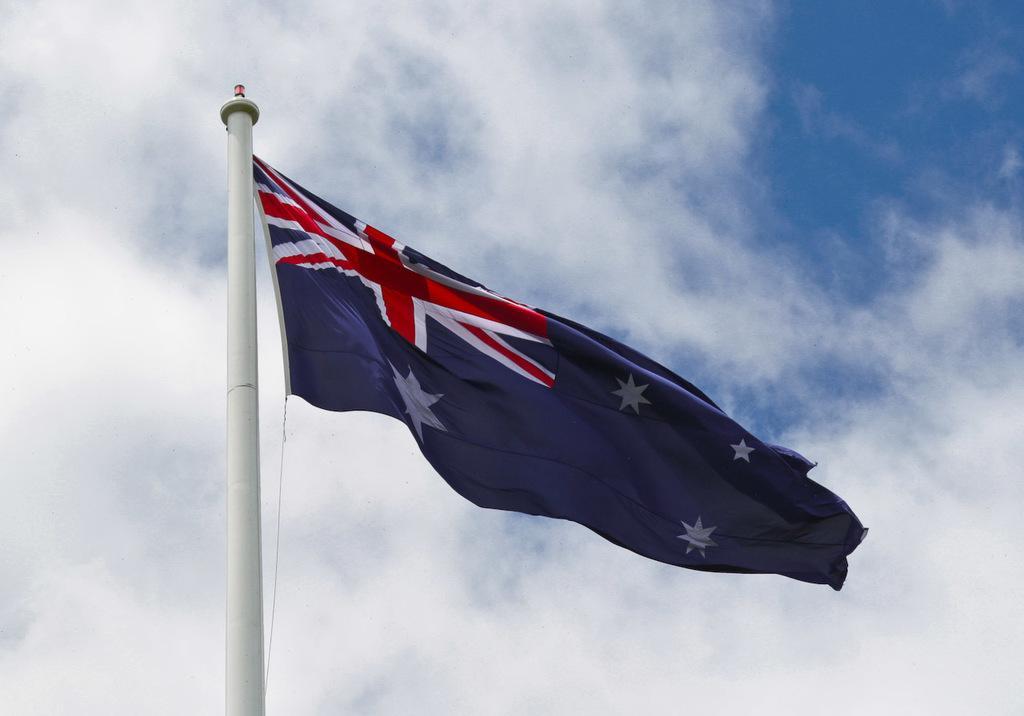How would you summarize this image in a sentence or two? In this picture I can see a white color pole in front and on it I can see a flag which is of white, blue and red color. In the background I can see the clear sky. 